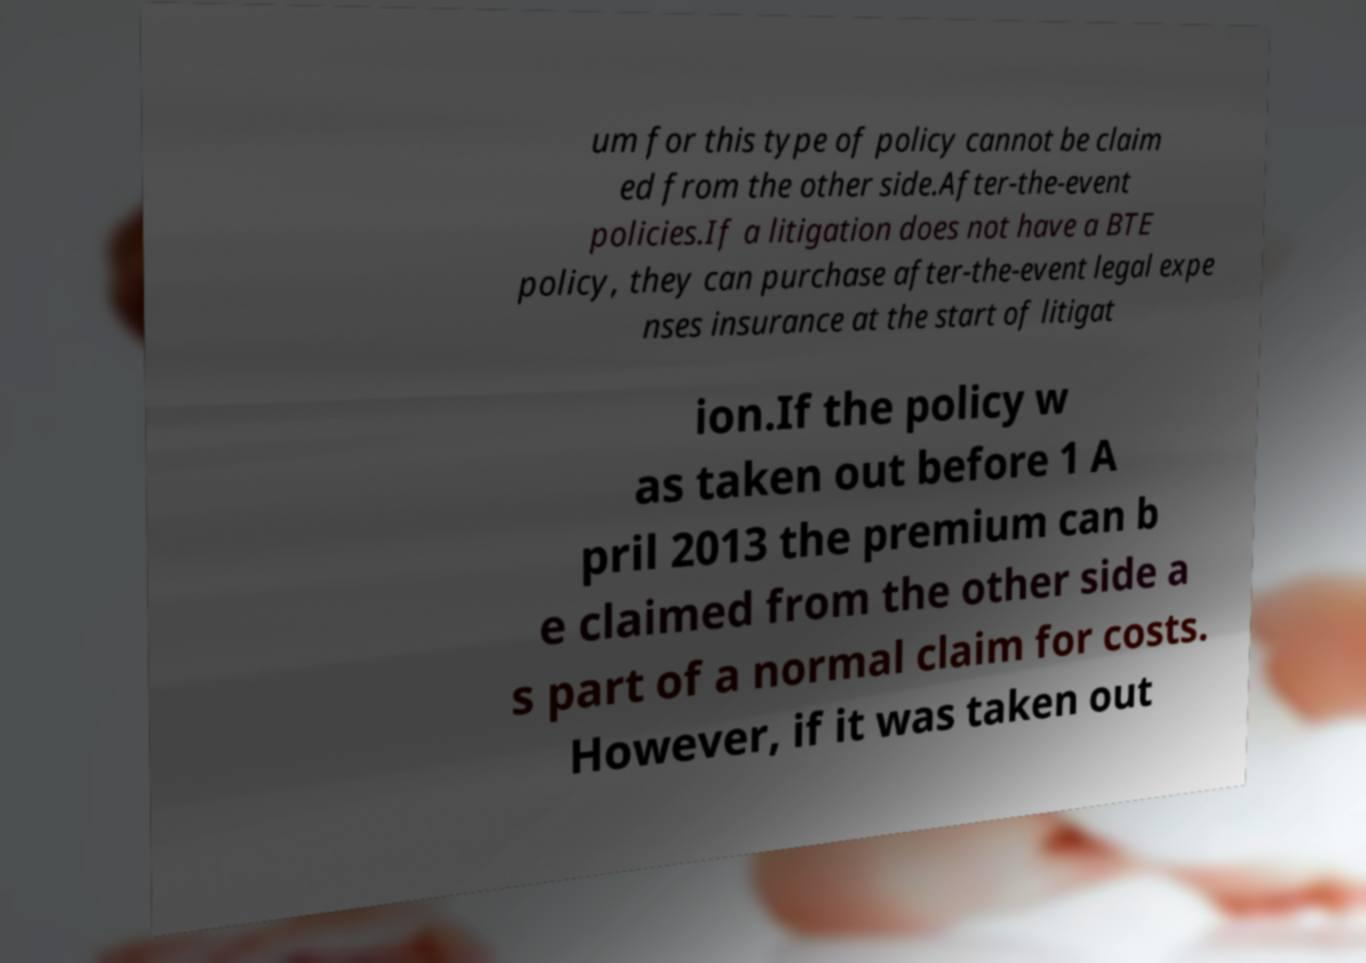I need the written content from this picture converted into text. Can you do that? um for this type of policy cannot be claim ed from the other side.After-the-event policies.If a litigation does not have a BTE policy, they can purchase after-the-event legal expe nses insurance at the start of litigat ion.If the policy w as taken out before 1 A pril 2013 the premium can b e claimed from the other side a s part of a normal claim for costs. However, if it was taken out 